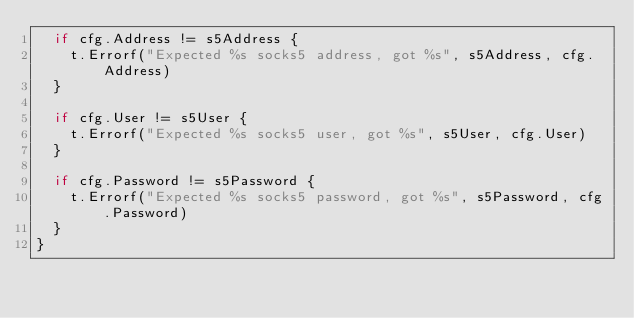Convert code to text. <code><loc_0><loc_0><loc_500><loc_500><_Go_>	if cfg.Address != s5Address {
		t.Errorf("Expected %s socks5 address, got %s", s5Address, cfg.Address)
	}

	if cfg.User != s5User {
		t.Errorf("Expected %s socks5 user, got %s", s5User, cfg.User)
	}

	if cfg.Password != s5Password {
		t.Errorf("Expected %s socks5 password, got %s", s5Password, cfg.Password)
	}
}
</code> 